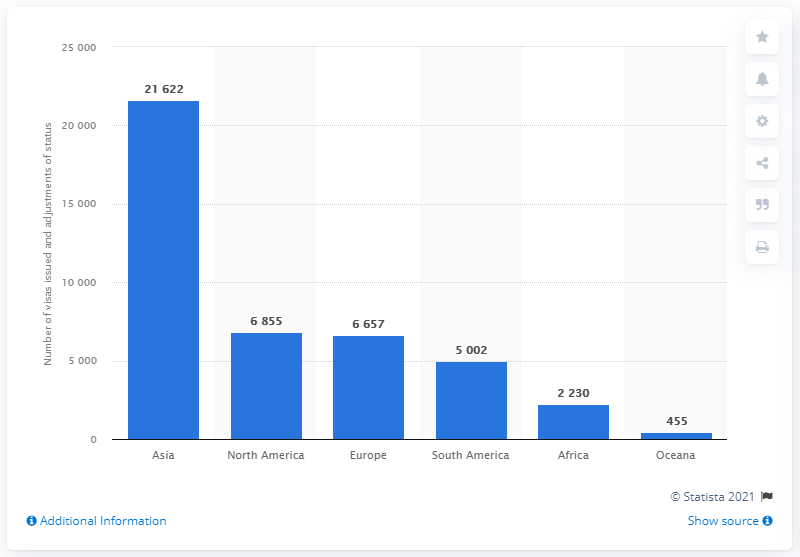List a handful of essential elements in this visual. In the fiscal year of 2020, a total of 455 EB-3 visa issuances and status adjustments were made to immigrants from Oceania. 